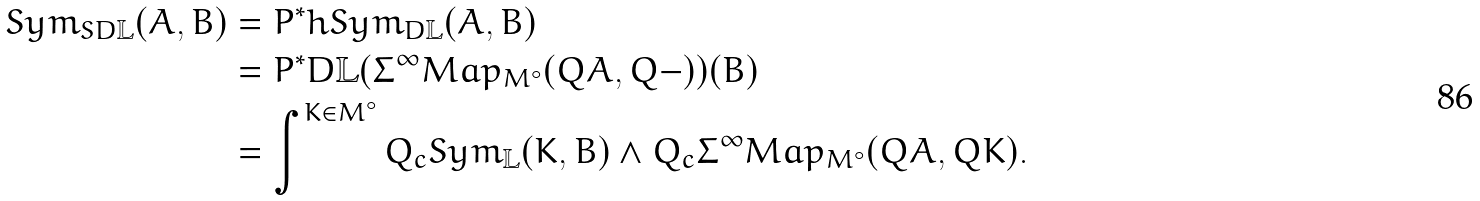Convert formula to latex. <formula><loc_0><loc_0><loc_500><loc_500>S y m _ { S D \mathbb { L } } ( A , B ) & = P ^ { * } h S y m _ { D \mathbb { L } } ( A , B ) \\ & = P ^ { * } D \mathbb { L } ( \Sigma ^ { \infty } M a p _ { M ^ { \circ } } ( Q A , Q - ) ) ( B ) \\ & = \int ^ { K \in M ^ { \circ } } Q _ { c } S y m _ { \mathbb { L } } ( K , B ) \wedge Q _ { c } \Sigma ^ { \infty } M a p _ { M ^ { \circ } } ( Q A , Q K ) .</formula> 